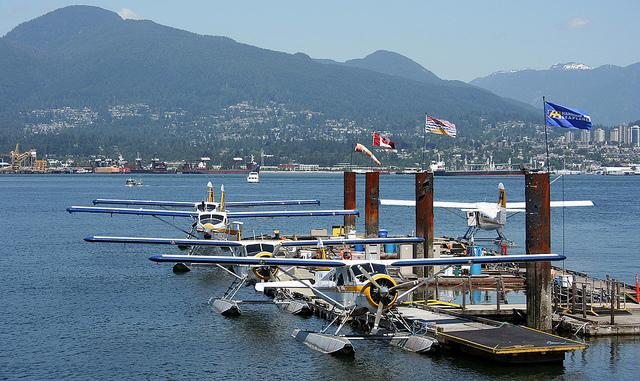What are the planes near the dock called?

Choices:
A) airbus
B) jet
C) commuter
D) seaplane seaplane 